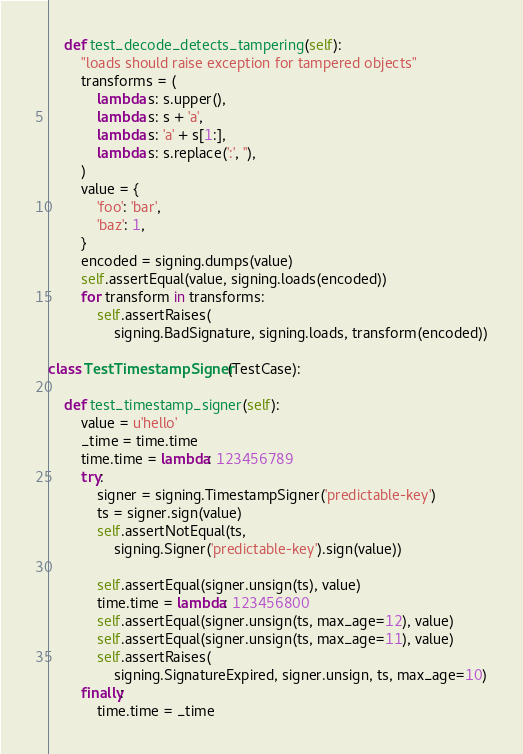Convert code to text. <code><loc_0><loc_0><loc_500><loc_500><_Python_>
    def test_decode_detects_tampering(self):
        "loads should raise exception for tampered objects"
        transforms = (
            lambda s: s.upper(),
            lambda s: s + 'a',
            lambda s: 'a' + s[1:],
            lambda s: s.replace(':', ''),
        )
        value = {
            'foo': 'bar',
            'baz': 1,
        }
        encoded = signing.dumps(value)
        self.assertEqual(value, signing.loads(encoded))
        for transform in transforms:
            self.assertRaises(
                signing.BadSignature, signing.loads, transform(encoded))

class TestTimestampSigner(TestCase):

    def test_timestamp_signer(self):
        value = u'hello'
        _time = time.time
        time.time = lambda: 123456789
        try:
            signer = signing.TimestampSigner('predictable-key')
            ts = signer.sign(value)
            self.assertNotEqual(ts,
                signing.Signer('predictable-key').sign(value))

            self.assertEqual(signer.unsign(ts), value)
            time.time = lambda: 123456800
            self.assertEqual(signer.unsign(ts, max_age=12), value)
            self.assertEqual(signer.unsign(ts, max_age=11), value)
            self.assertRaises(
                signing.SignatureExpired, signer.unsign, ts, max_age=10)
        finally:
            time.time = _time
</code> 